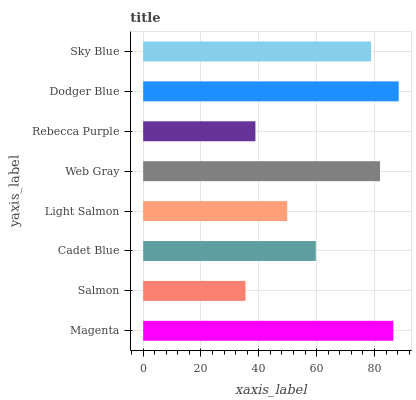Is Salmon the minimum?
Answer yes or no. Yes. Is Dodger Blue the maximum?
Answer yes or no. Yes. Is Cadet Blue the minimum?
Answer yes or no. No. Is Cadet Blue the maximum?
Answer yes or no. No. Is Cadet Blue greater than Salmon?
Answer yes or no. Yes. Is Salmon less than Cadet Blue?
Answer yes or no. Yes. Is Salmon greater than Cadet Blue?
Answer yes or no. No. Is Cadet Blue less than Salmon?
Answer yes or no. No. Is Sky Blue the high median?
Answer yes or no. Yes. Is Cadet Blue the low median?
Answer yes or no. Yes. Is Rebecca Purple the high median?
Answer yes or no. No. Is Magenta the low median?
Answer yes or no. No. 